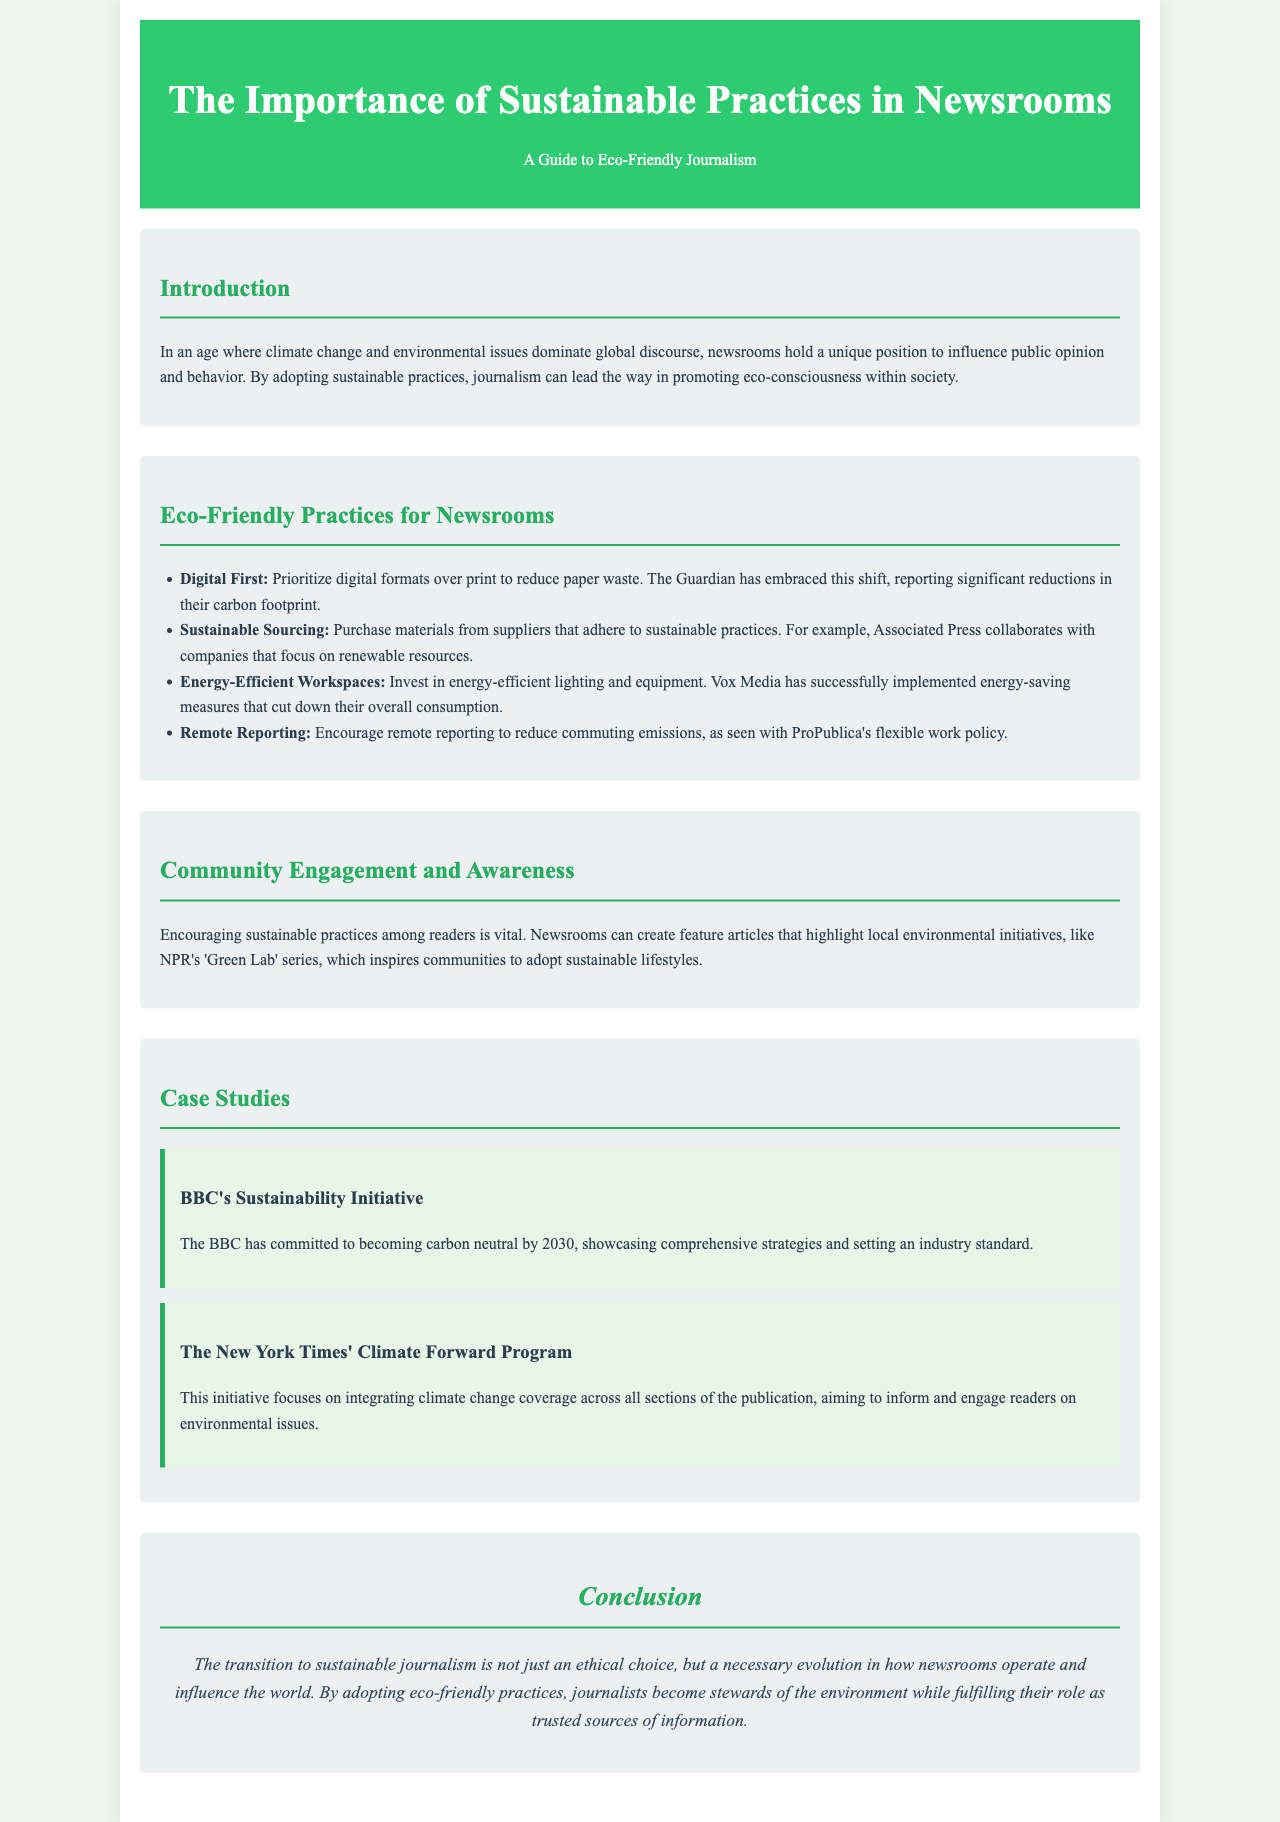what is the title of the document? The title of the document is the main heading found at the top of the brochure.
Answer: The Importance of Sustainable Practices in Newsrooms what is one eco-friendly practice suggested for newsrooms? The document lists various eco-friendly practices for newsrooms in a bullet format.
Answer: Digital First which organization aims to become carbon neutral by 2030? The document provides a specific case study highlighting the efforts of an organization related to sustainability.
Answer: BBC what type of articles can newsrooms create to encourage sustainable practices? The document mentions specific types of content that can be produced to foster community engagement.
Answer: Feature articles what initiative does The New York Times focus on? A case study in the document outlines a specific initiative of The New York Times related to climate coverage.
Answer: Climate Forward Program how does ProPublica reduce commuting emissions? The document discusses remote reporting as a means to lower emissions related to commuting.
Answer: Remote reporting what color represents the header background of the brochure? The style information in the document specifies the background color of the header.
Answer: Green how many case studies are presented in the document? The number of case studies can be determined by counting the instances presented in the case studies section.
Answer: Two 